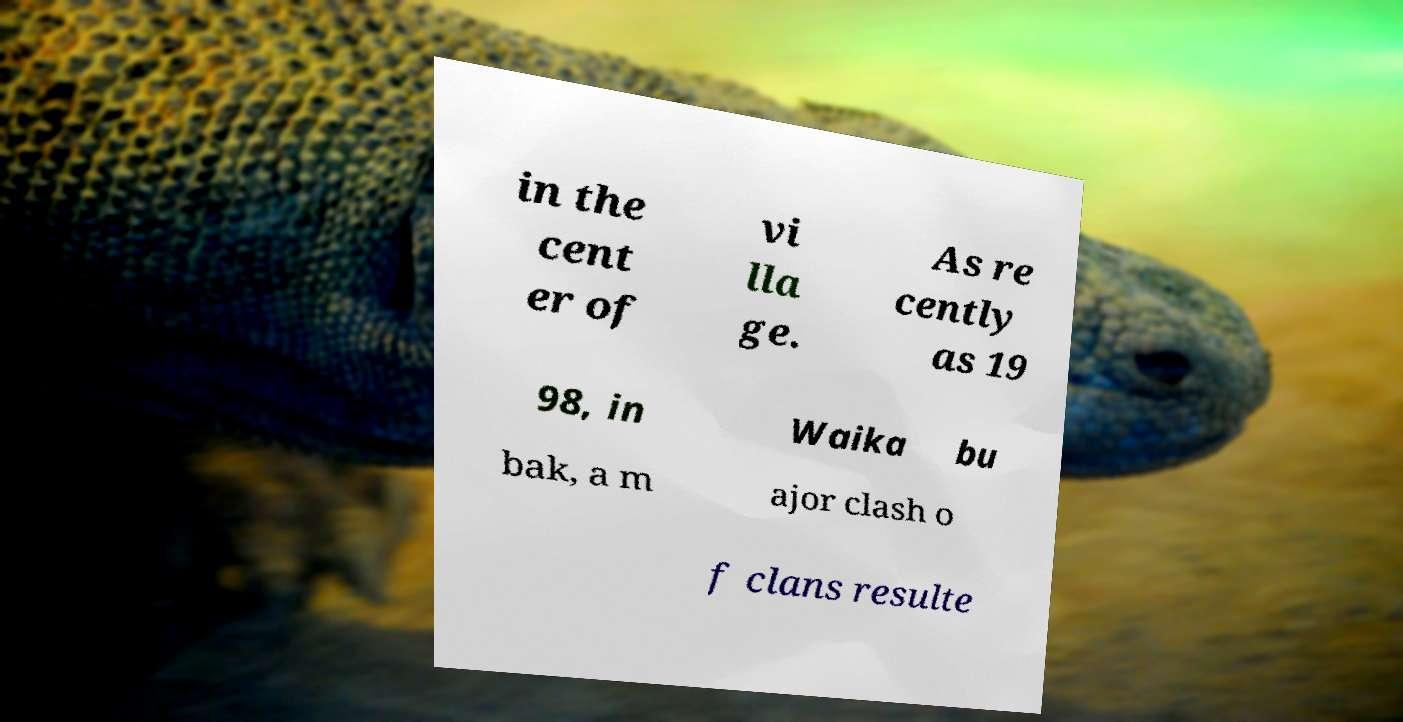Could you assist in decoding the text presented in this image and type it out clearly? in the cent er of vi lla ge. As re cently as 19 98, in Waika bu bak, a m ajor clash o f clans resulte 